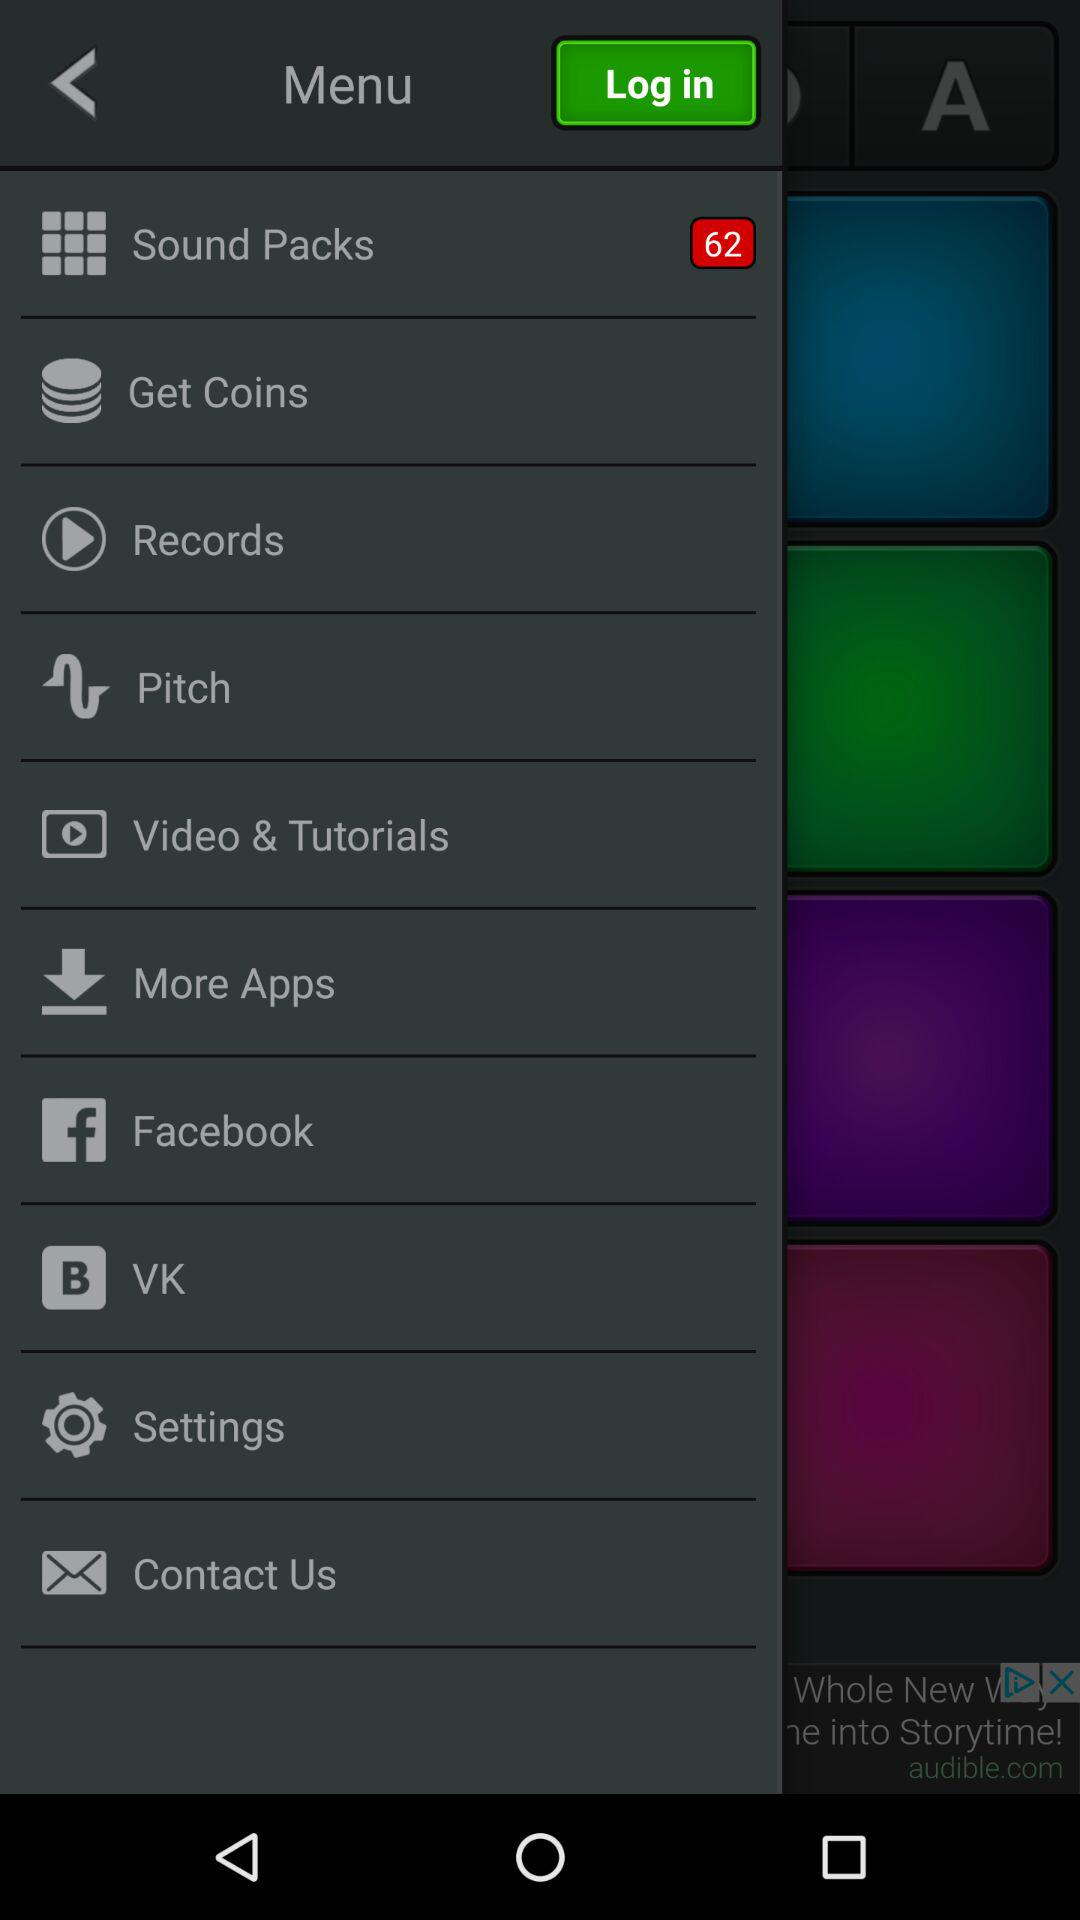How many items are in "Sound Packs"? There are 62 items. 